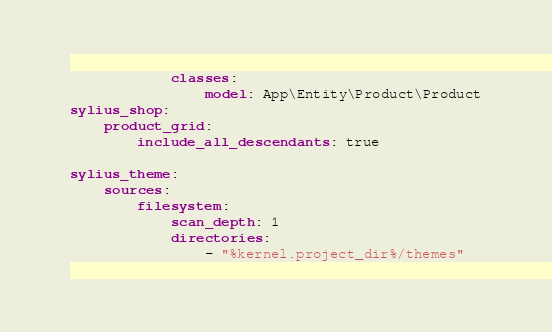Convert code to text. <code><loc_0><loc_0><loc_500><loc_500><_YAML_>            classes:
                model: App\Entity\Product\Product
sylius_shop:
    product_grid:
        include_all_descendants: true

sylius_theme:
    sources:
        filesystem:
            scan_depth: 1
            directories:
                - "%kernel.project_dir%/themes"
</code> 